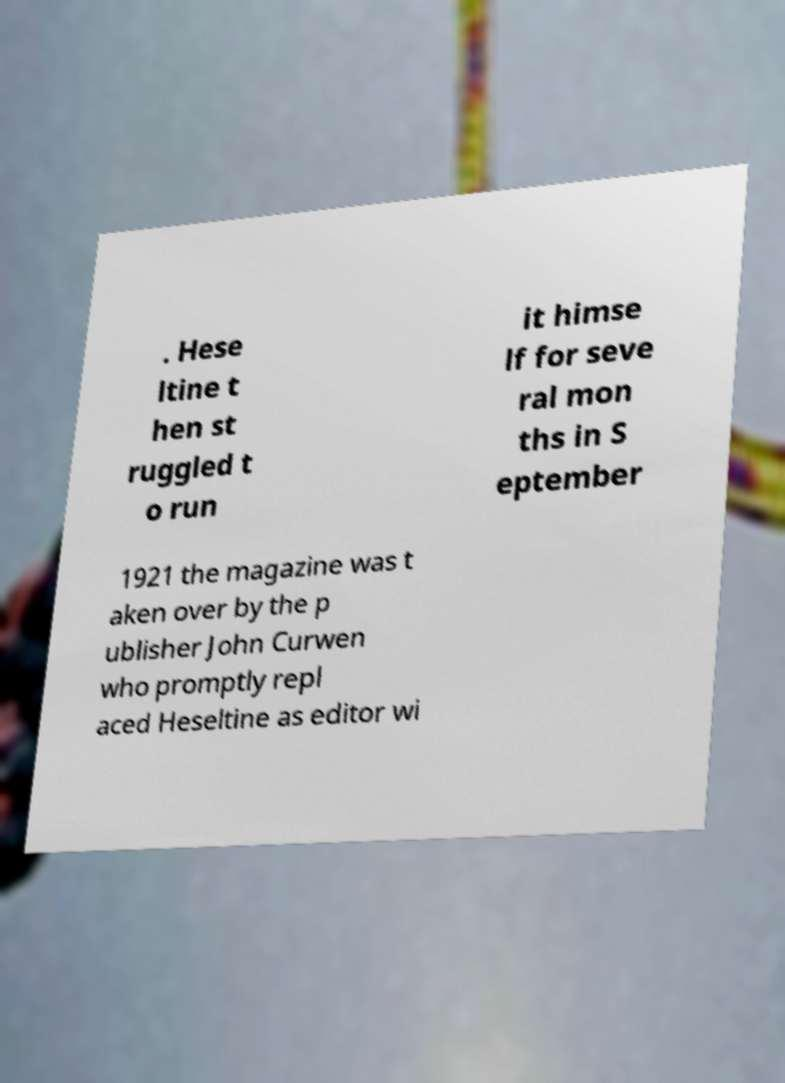There's text embedded in this image that I need extracted. Can you transcribe it verbatim? . Hese ltine t hen st ruggled t o run it himse lf for seve ral mon ths in S eptember 1921 the magazine was t aken over by the p ublisher John Curwen who promptly repl aced Heseltine as editor wi 